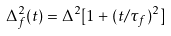<formula> <loc_0><loc_0><loc_500><loc_500>\Delta _ { f } ^ { 2 } ( t ) = \Delta ^ { 2 } [ 1 + ( t / \tau _ { f } ) ^ { 2 } ]</formula> 